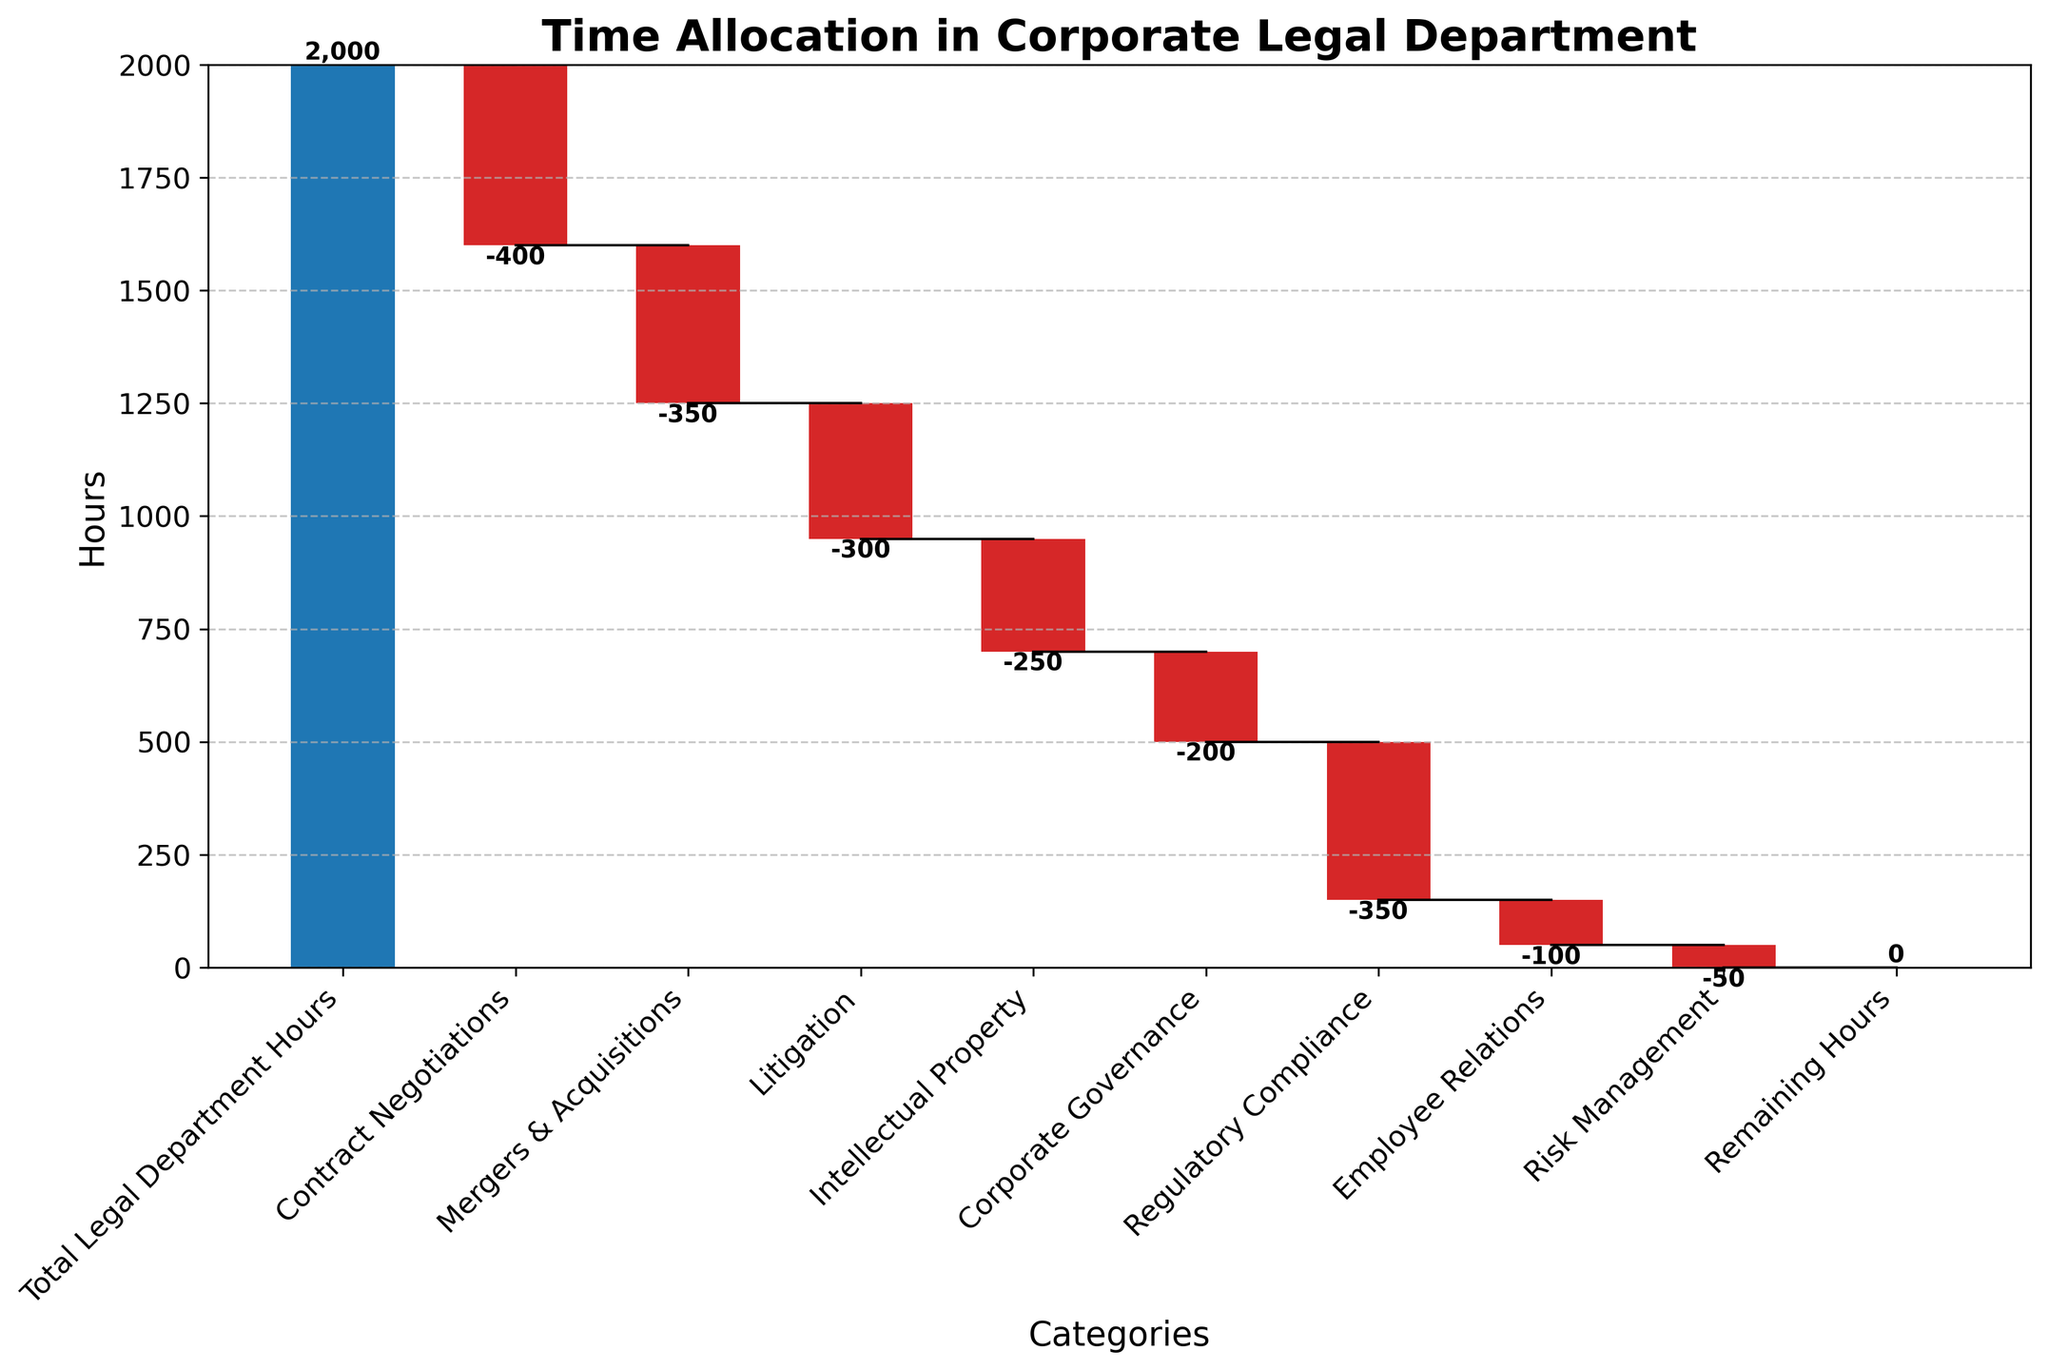What's the total number of hours allocated across all categories? The data shows that the Total Legal Department Hours is 2000. Sum all the reductions: 400 + 350 + 300 + 250 + 200 + 350 + 100 + 50, which equals 2000. 2000 - 2000 equals 0, matching the chart's remaining hours.
Answer: 2000 Which category has the highest allocation of hours after the total legal department hours? Contract Negotiations has the highest reduction in hours with 400 hours. All other categories have lesser hours allocated.
Answer: Contract Negotiations What is the cumulative hour count after handling regulatory compliance issues? Start with the total hours of 2000 and subtract the hours for Contract Negotiations, Mergers & Acquisitions, Litigation, Intellectual Property, Corporate Governance, and Regulatory Compliance. That's 2000 - 400 - 350 - 300 - 250 - 200 - 350 = 150.
Answer: 150 How do the hours spent on Mergers & Acquisitions compare to those on Litigation? Mergers & Acquisitions have a total of 350 hours spent, while Litigation has 300 hours spent.
Answer: Mergers & Acquisitions > Litigation What percentage of the total legal department hours is allocated to Intellectual Property? Determine the ratio of Intellectual Property hours (250) to total hours (2000), percentage = (250/2000) * 100%. That equals 12.5%.
Answer: 12.5% What is the next category allocation after Contract Negotiations? The next category after Contract Negotiations is Mergers & Acquisitions, which is shown right next to it on the plot.
Answer: Mergers & Acquisitions Which categories have lesser hours allocated compared to Regulatory Compliance? Regulatory Compliance has 350 hours allocated. The categories with lesser hours are Litigation (300), Intellectual Property (250), Corporate Governance (200), Employee Relations (100), and Risk Management (50).
Answer: Litigation, Intellectual Property, Corporate Governance, Employee Relations, Risk Management How do the hours for Employee Relations compare with those for Risk Management? Employee Relations have 100 hours allocated, while Risk Management has 50 hours. 100 - 50 = 50 hours more allocated to Employee Relations.
Answer: Employee Relations > Risk Management 